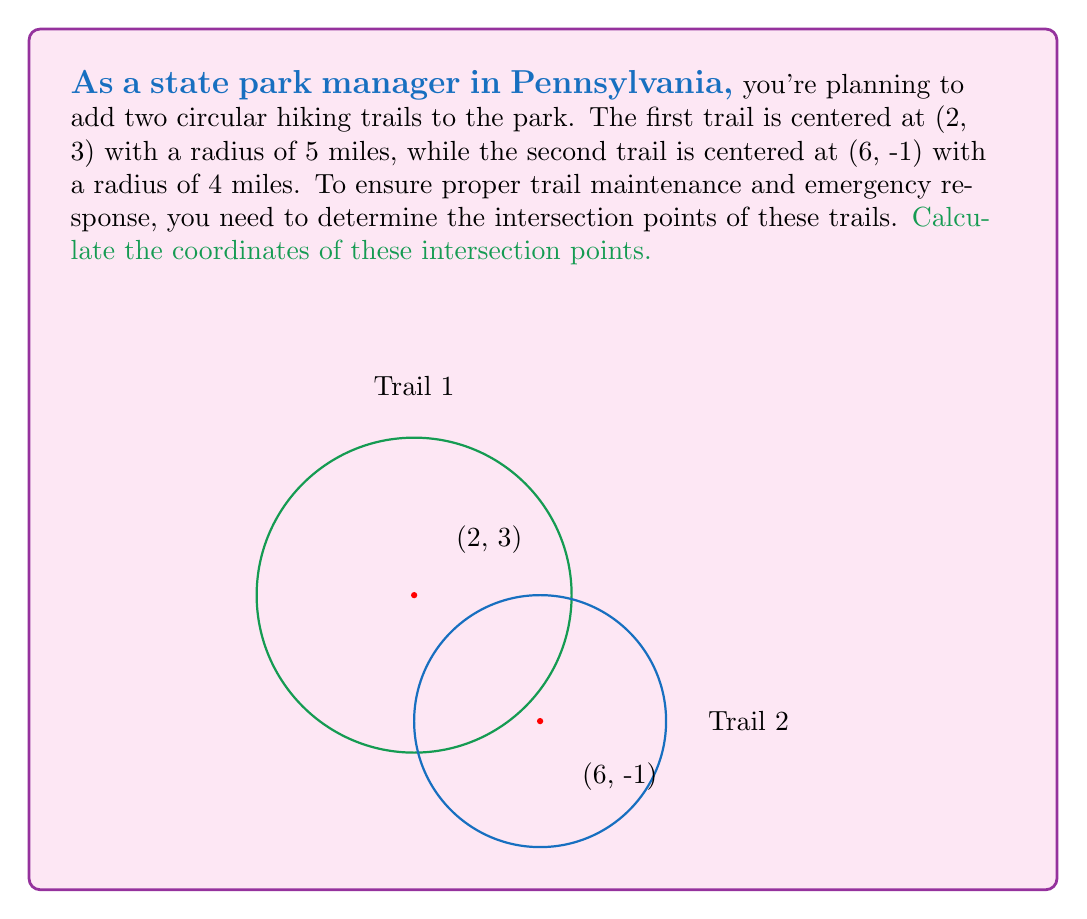Could you help me with this problem? Let's solve this step-by-step:

1) The equations of the two circular trails are:

   Trail 1: $$(x-2)^2 + (y-3)^2 = 5^2 = 25$$
   Trail 2: $$(x-6)^2 + (y+1)^2 = 4^2 = 16$$

2) To find the intersection points, we need to solve these equations simultaneously.

3) Expand the equations:
   $$x^2 - 4x + 4 + y^2 - 6y + 9 = 25$$
   $$x^2 - 12x + 36 + y^2 + 2y + 1 = 16$$

4) Subtract the second equation from the first:
   $$8x - 8y - 32 + 8 = 9$$
   $$8x - 8y = 33$$
   $$x - y = \frac{33}{8}$$

5) Substitute this into the equation of Trail 1:
   $$(x-2)^2 + (x - \frac{33}{8} - 3)^2 = 25$$

6) Expand and simplify:
   $$x^2 - 4x + 4 + x^2 - \frac{33x}{4} - 3x + \frac{1089}{64} + 9 + \frac{99}{8} = 25$$
   $$2x^2 - \frac{49x}{4} + \frac{1377}{64} - 12 = 0$$

7) Multiply everything by 64:
   $$128x^2 - 784x + 1377 = 0$$

8) This is a quadratic equation. Solve using the quadratic formula:
   $$x = \frac{784 \pm \sqrt{784^2 - 4(128)(1377)}}{2(128)}$$

9) Simplify:
   $$x = \frac{784 \pm \sqrt{614656 - 704512}}{256} = \frac{784 \pm \sqrt{-89856}}{256}$$
   $$x = \frac{784 \pm 300i}{256}$$

10) The real solutions are:
    $$x_1 = \frac{784 + 300}{256} = \frac{1084}{256} \approx 4.234375$$
    $$x_2 = \frac{784 - 300}{256} = \frac{484}{256} \approx 1.890625$$

11) Find the corresponding y-values using $x - y = \frac{33}{8}$:
    $$y_1 = x_1 - \frac{33}{8} \approx 0.109375$$
    $$y_2 = x_2 - \frac{33}{8} \approx -2.234375$$
Answer: (4.234375, 0.109375) and (1.890625, -2.234375) 